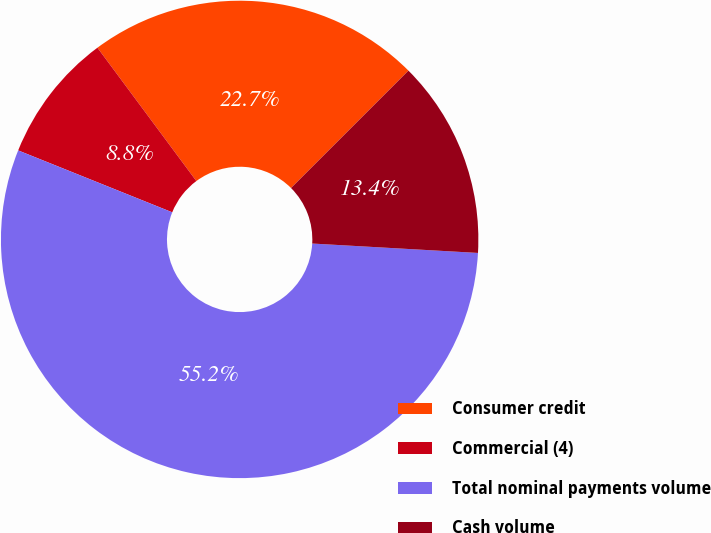Convert chart to OTSL. <chart><loc_0><loc_0><loc_500><loc_500><pie_chart><fcel>Consumer credit<fcel>Commercial (4)<fcel>Total nominal payments volume<fcel>Cash volume<nl><fcel>22.66%<fcel>8.76%<fcel>55.18%<fcel>13.4%<nl></chart> 